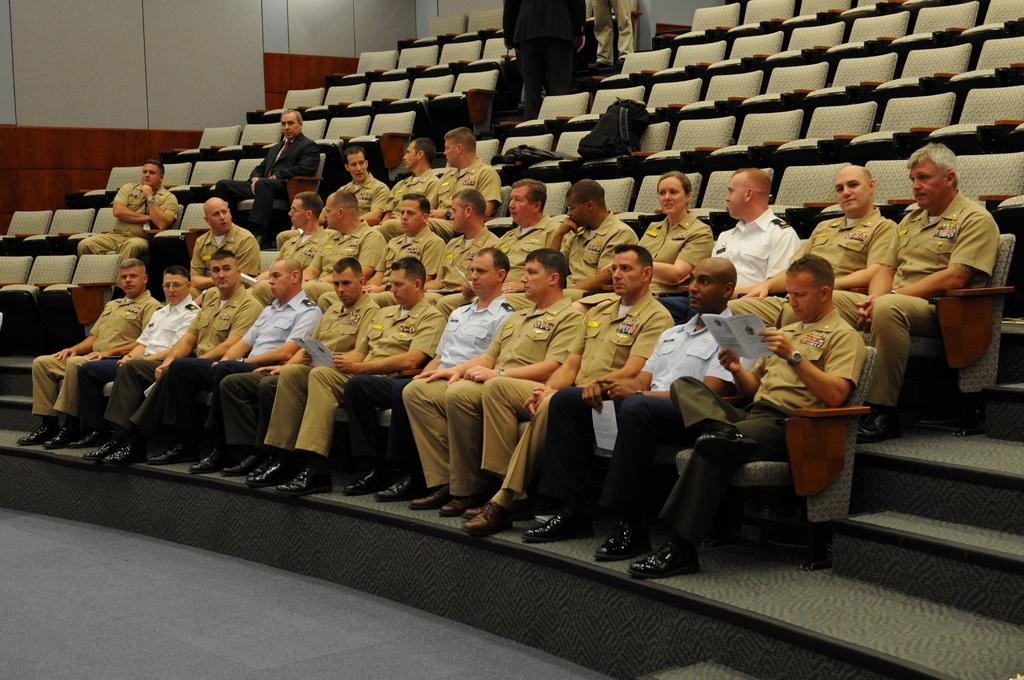In one or two sentences, can you explain what this image depicts? In this picture we can see a few people sitting on the chair. There are a few people holding books in their hands. We can see the bags on the chairs. There are a few people standing on top of the picture. 